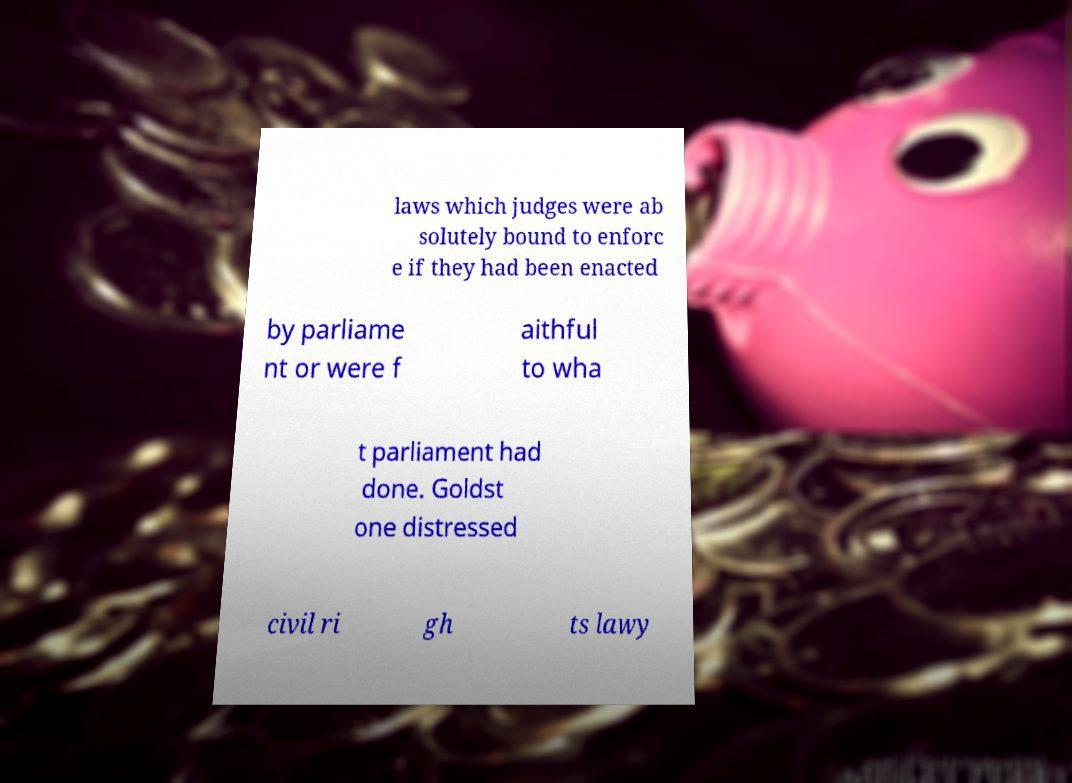Can you accurately transcribe the text from the provided image for me? laws which judges were ab solutely bound to enforc e if they had been enacted by parliame nt or were f aithful to wha t parliament had done. Goldst one distressed civil ri gh ts lawy 